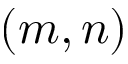Convert formula to latex. <formula><loc_0><loc_0><loc_500><loc_500>( m , n )</formula> 